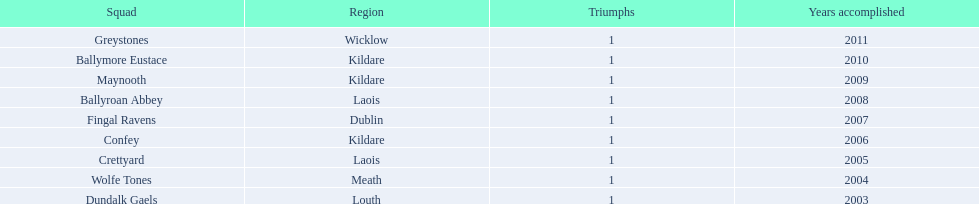Where is ballymore eustace from? Kildare. What teams other than ballymore eustace is from kildare? Maynooth, Confey. Between maynooth and confey, which won in 2009? Maynooth. 